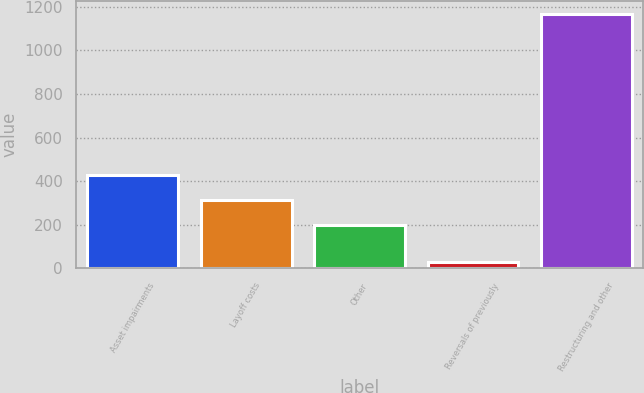Convert chart. <chart><loc_0><loc_0><loc_500><loc_500><bar_chart><fcel>Asset impairments<fcel>Layoff costs<fcel>Other<fcel>Reversals of previously<fcel>Restructuring and other<nl><fcel>427<fcel>313<fcel>199<fcel>28<fcel>1168<nl></chart> 